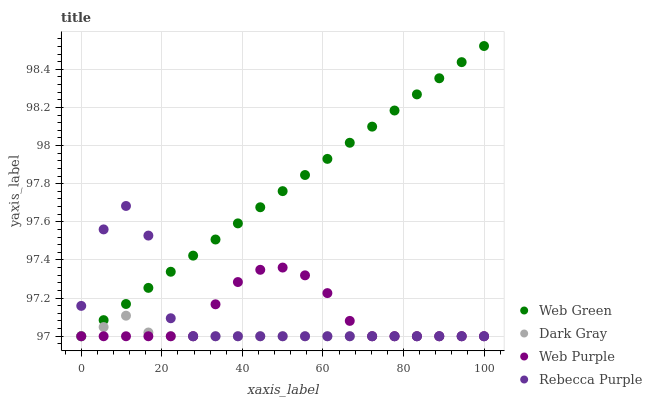Does Dark Gray have the minimum area under the curve?
Answer yes or no. Yes. Does Web Green have the maximum area under the curve?
Answer yes or no. Yes. Does Web Purple have the minimum area under the curve?
Answer yes or no. No. Does Web Purple have the maximum area under the curve?
Answer yes or no. No. Is Web Green the smoothest?
Answer yes or no. Yes. Is Rebecca Purple the roughest?
Answer yes or no. Yes. Is Web Purple the smoothest?
Answer yes or no. No. Is Web Purple the roughest?
Answer yes or no. No. Does Dark Gray have the lowest value?
Answer yes or no. Yes. Does Web Green have the highest value?
Answer yes or no. Yes. Does Web Purple have the highest value?
Answer yes or no. No. Does Rebecca Purple intersect Web Green?
Answer yes or no. Yes. Is Rebecca Purple less than Web Green?
Answer yes or no. No. Is Rebecca Purple greater than Web Green?
Answer yes or no. No. 